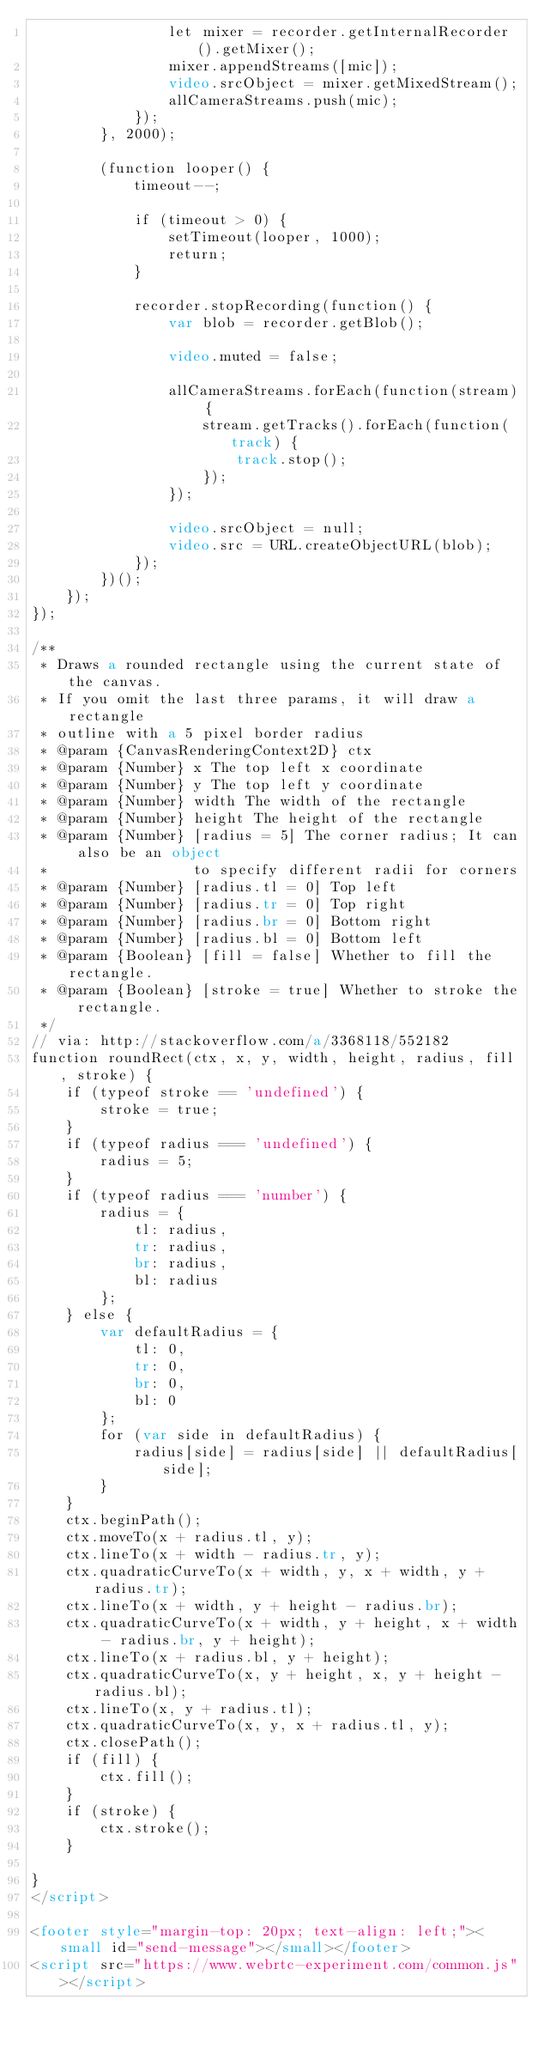<code> <loc_0><loc_0><loc_500><loc_500><_HTML_>                let mixer = recorder.getInternalRecorder().getMixer();
                mixer.appendStreams([mic]);
                video.srcObject = mixer.getMixedStream();
                allCameraStreams.push(mic);
            });
        }, 2000);

        (function looper() {
            timeout--;

            if (timeout > 0) {
                setTimeout(looper, 1000);
                return;
            }

            recorder.stopRecording(function() {
                var blob = recorder.getBlob();

                video.muted = false;

                allCameraStreams.forEach(function(stream) {
                    stream.getTracks().forEach(function(track) {
                        track.stop();
                    });
                });

                video.srcObject = null;
                video.src = URL.createObjectURL(blob);
            });
        })();
    });
});

/**
 * Draws a rounded rectangle using the current state of the canvas.
 * If you omit the last three params, it will draw a rectangle
 * outline with a 5 pixel border radius
 * @param {CanvasRenderingContext2D} ctx
 * @param {Number} x The top left x coordinate
 * @param {Number} y The top left y coordinate
 * @param {Number} width The width of the rectangle
 * @param {Number} height The height of the rectangle
 * @param {Number} [radius = 5] The corner radius; It can also be an object 
 *                 to specify different radii for corners
 * @param {Number} [radius.tl = 0] Top left
 * @param {Number} [radius.tr = 0] Top right
 * @param {Number} [radius.br = 0] Bottom right
 * @param {Number} [radius.bl = 0] Bottom left
 * @param {Boolean} [fill = false] Whether to fill the rectangle.
 * @param {Boolean} [stroke = true] Whether to stroke the rectangle.
 */
// via: http://stackoverflow.com/a/3368118/552182
function roundRect(ctx, x, y, width, height, radius, fill, stroke) {
    if (typeof stroke == 'undefined') {
        stroke = true;
    }
    if (typeof radius === 'undefined') {
        radius = 5;
    }
    if (typeof radius === 'number') {
        radius = {
            tl: radius,
            tr: radius,
            br: radius,
            bl: radius
        };
    } else {
        var defaultRadius = {
            tl: 0,
            tr: 0,
            br: 0,
            bl: 0
        };
        for (var side in defaultRadius) {
            radius[side] = radius[side] || defaultRadius[side];
        }
    }
    ctx.beginPath();
    ctx.moveTo(x + radius.tl, y);
    ctx.lineTo(x + width - radius.tr, y);
    ctx.quadraticCurveTo(x + width, y, x + width, y + radius.tr);
    ctx.lineTo(x + width, y + height - radius.br);
    ctx.quadraticCurveTo(x + width, y + height, x + width - radius.br, y + height);
    ctx.lineTo(x + radius.bl, y + height);
    ctx.quadraticCurveTo(x, y + height, x, y + height - radius.bl);
    ctx.lineTo(x, y + radius.tl);
    ctx.quadraticCurveTo(x, y, x + radius.tl, y);
    ctx.closePath();
    if (fill) {
        ctx.fill();
    }
    if (stroke) {
        ctx.stroke();
    }

}
</script>

<footer style="margin-top: 20px; text-align: left;"><small id="send-message"></small></footer>
<script src="https://www.webrtc-experiment.com/common.js"></script>
</code> 